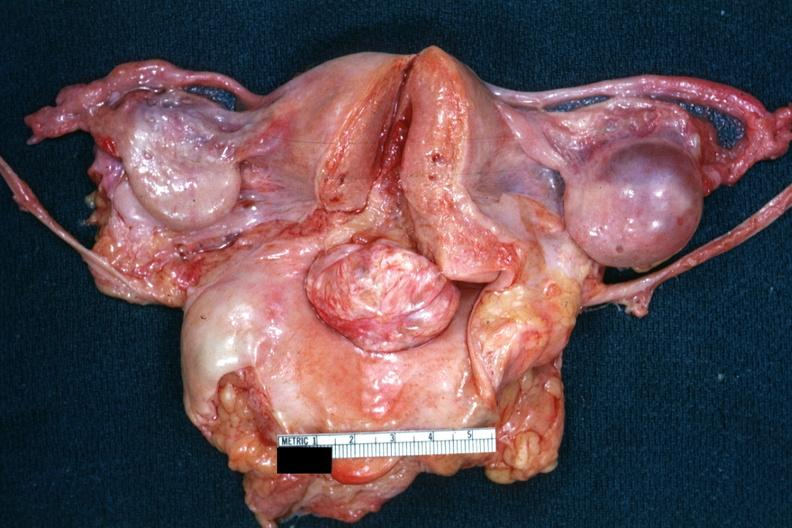where does this belong to?
Answer the question using a single word or phrase. Female reproductive system 